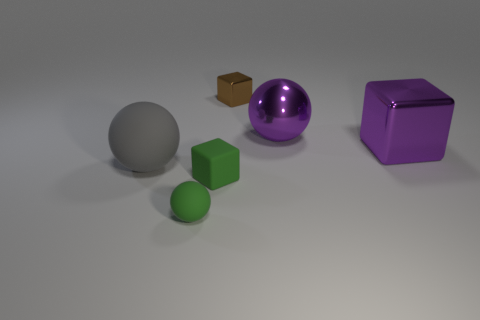Add 3 large yellow matte objects. How many objects exist? 9 Subtract all large purple cubes. How many cubes are left? 2 Subtract all yellow balls. Subtract all large gray matte balls. How many objects are left? 5 Add 4 brown objects. How many brown objects are left? 5 Add 2 matte spheres. How many matte spheres exist? 4 Subtract 1 purple blocks. How many objects are left? 5 Subtract all gray blocks. Subtract all gray balls. How many blocks are left? 3 